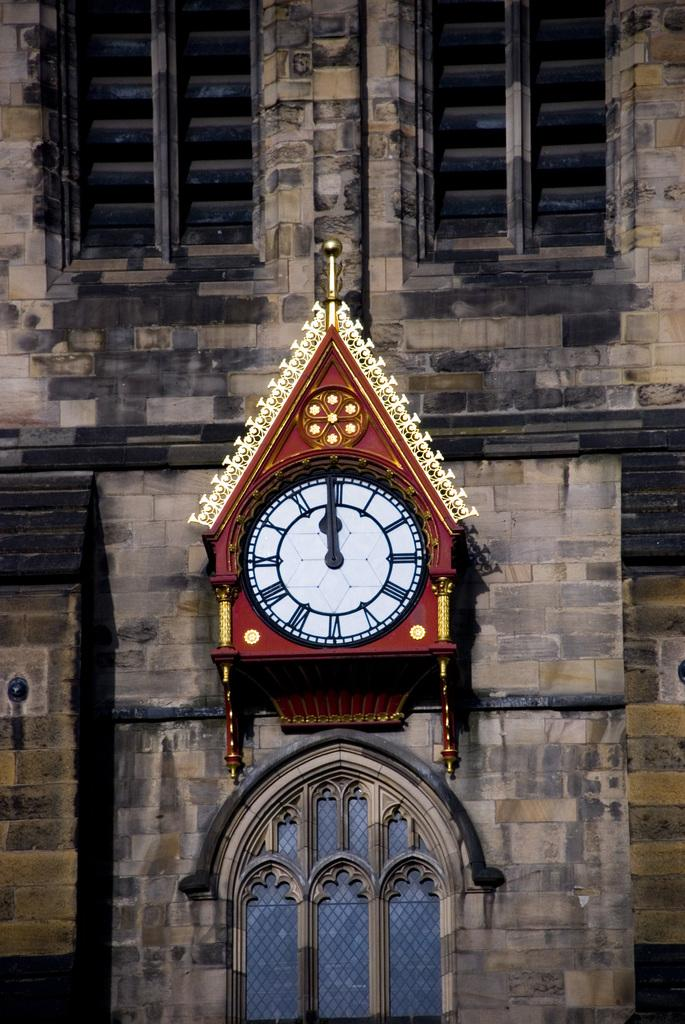<image>
Write a terse but informative summary of the picture. Red clock with both hands on the number 12. 